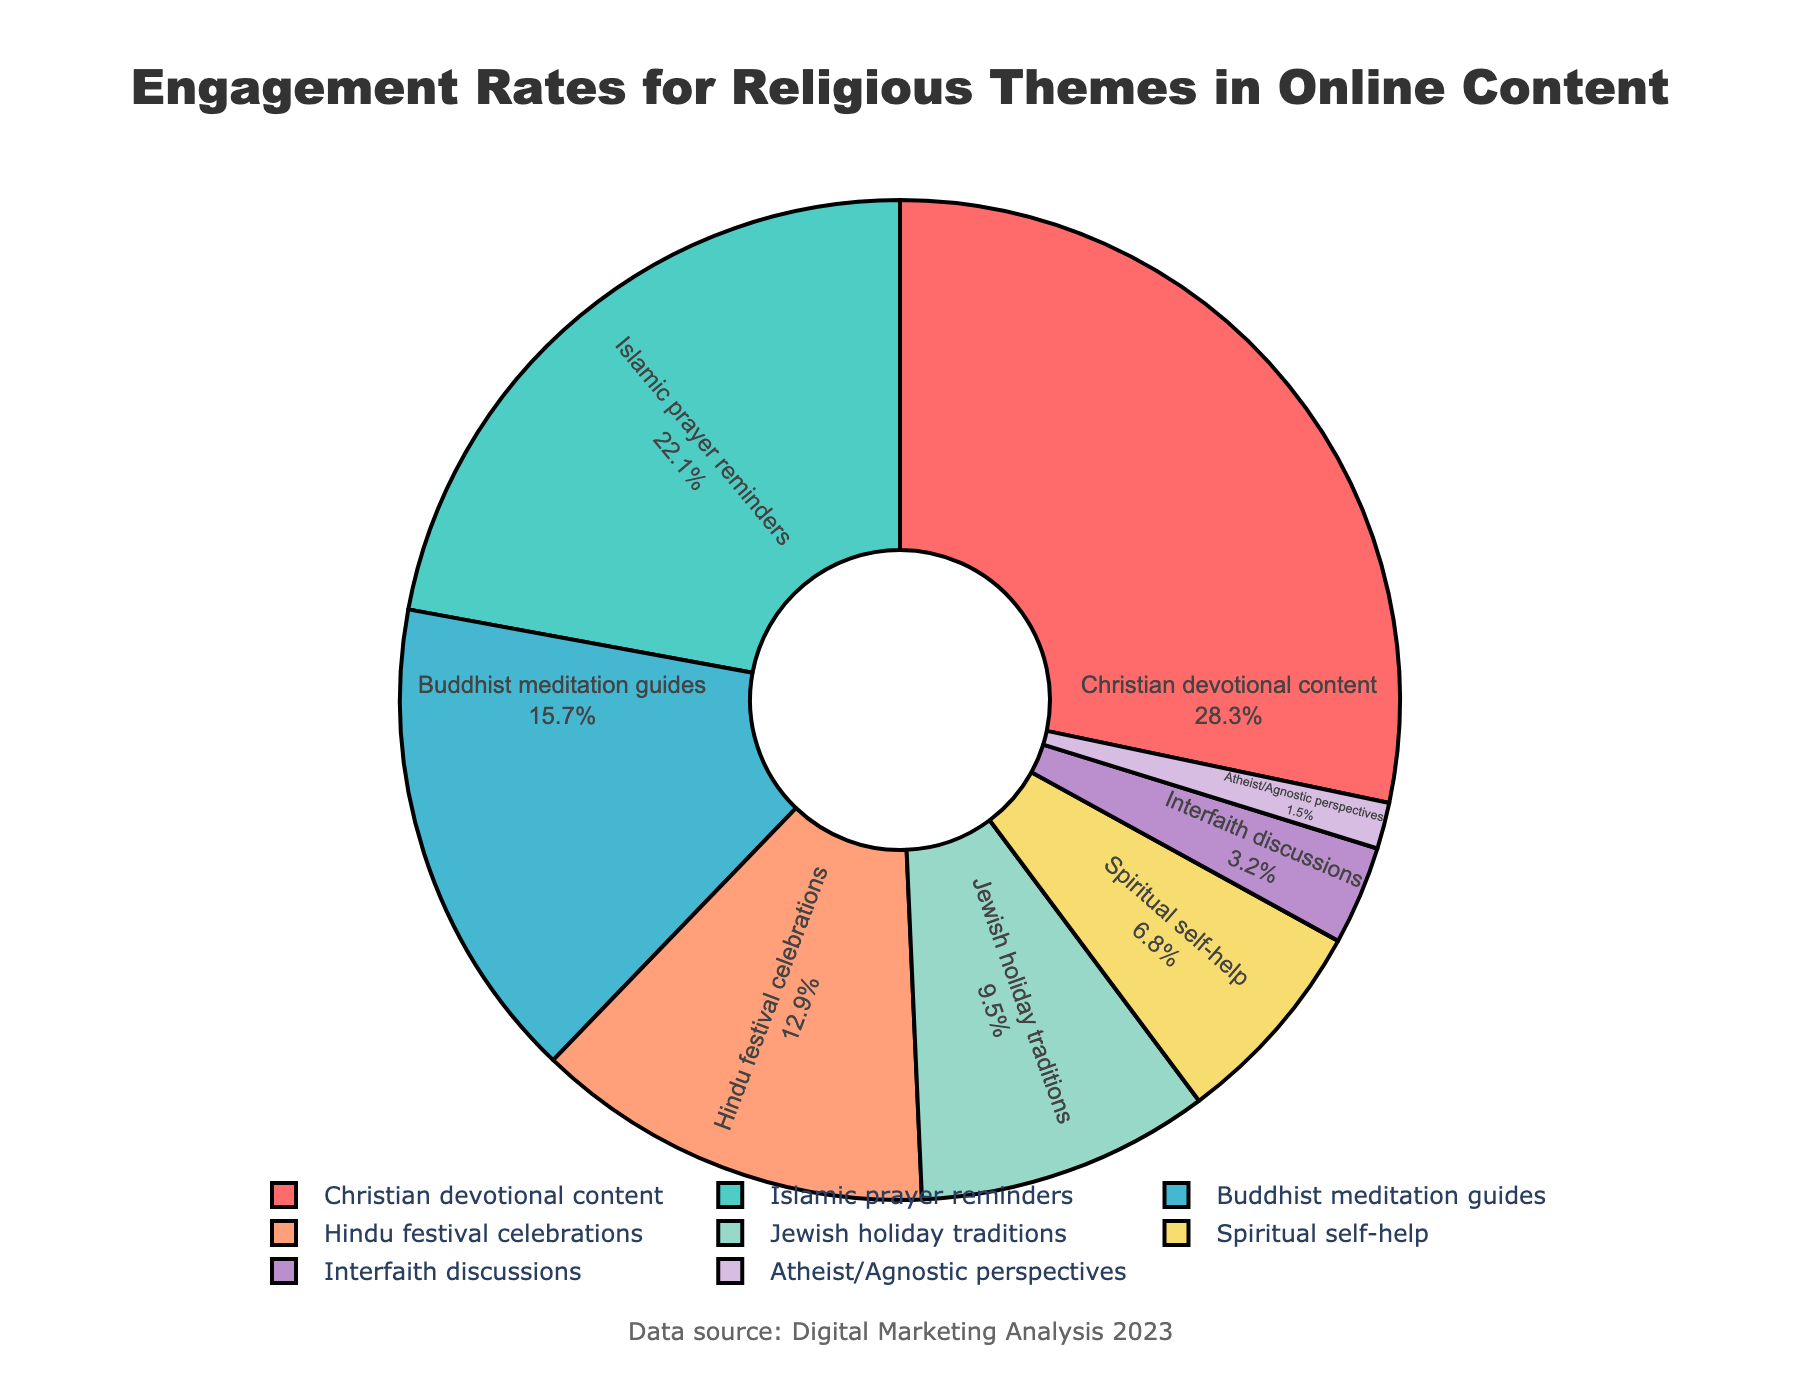Which theme has the highest engagement rate? The highest slab in the pie chart represents the theme with the largest percentage. "Christian devotional content" has the largest section.
Answer: Christian devotional content What is the total engagement rate of Islamic prayer reminders and Buddhist meditation guides? To find the total, sum the engagement rates of "Islamic prayer reminders" (22.1) and "Buddhist meditation guides" (15.7). 22.1 + 15.7 = 37.8
Answer: 37.8 Which theme has the least engagement rate, and what is that rate? The smallest section of the pie chart represents the theme with the least engagement. "Atheist/Agnostic perspectives" has the smallest section, which is 1.5.
Answer: Atheist/Agnostic perspectives, 1.5 Compare the engagement rates of Hindu festival celebrations to Jewish holiday traditions. Which is higher? Observe the slices corresponding to "Hindu festival celebrations" (12.9) and "Jewish holiday traditions" (9.5). "Hindu festival celebrations" has a higher percentage.
Answer: Hindu festival celebrations What is the combined engagement rate of themes related to Christianity and Islam? Sum the engagement rates of "Christian devotional content" (28.3) and "Islamic prayer reminders" (22.1). 28.3 + 22.1 = 50.4
Answer: 50.4 If we group the engagement rates of Hindu festival celebrations and Jewish holiday traditions, how much higher would it be than Spiritual self-help? Calculate the total of "Hindu festival celebrations" (12.9) and "Jewish holiday traditions" (9.5) to get 22.4, then find the difference from "Spiritual self-help" (6.8). 22.4 - 6.8 = 15.6
Answer: 15.6 Rank the following themes by their engagement rates from highest to lowest: Spiritual self-help, Interfaith discussions, and Atheist/Agnostic perspectives. Compare the engagement rates: "Spiritual self-help" (6.8), "Interfaith discussions" (3.2), and "Atheist/Agnostic perspectives" (1.5). The ranking is Spiritual self-help > Interfaith discussions > Atheist/Agnostic perspectives.
Answer: Spiritual self-help, Interfaith discussions, Atheist/Agnostic perspectives What is the average engagement rate of all themes listed? Add the engagement rates of all themes and divide by the number of themes. The sum is 28.3 + 22.1 + 15.7 + 12.9 + 9.5 + 6.8 + 3.2 + 1.5 = 100, and there are 8 themes. 100 / 8 = 12.5
Answer: 12.5 Which themes have engagement rates higher than 20%? Identify themes with engagement rates above 20%: "Christian devotional content" (28.3), "Islamic prayer reminders" (22.1).
Answer: Christian devotional content, Islamic prayer reminders 